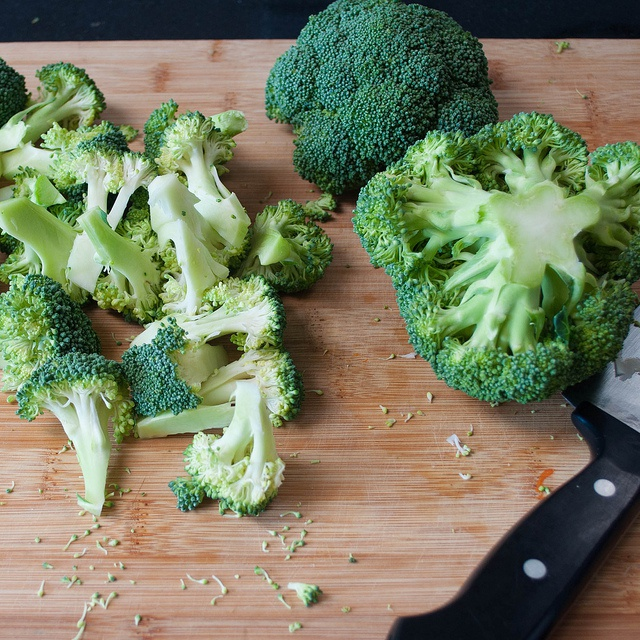Describe the objects in this image and their specific colors. I can see broccoli in black, beige, olive, lightgreen, and darkgreen tones, broccoli in black, darkgreen, green, and lightgreen tones, and knife in black, gray, and darkgray tones in this image. 